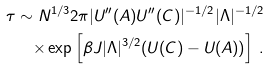Convert formula to latex. <formula><loc_0><loc_0><loc_500><loc_500>\tau \sim N ^ { 1 / 3 } 2 \pi | U ^ { \prime \prime } ( A ) U ^ { \prime \prime } ( C ) | ^ { - 1 / 2 } | \Lambda | ^ { - 1 / 2 } \\ \times \exp \left [ \beta J | \Lambda | ^ { 3 / 2 } ( U ( C ) - U ( A ) ) \right ] \, .</formula> 